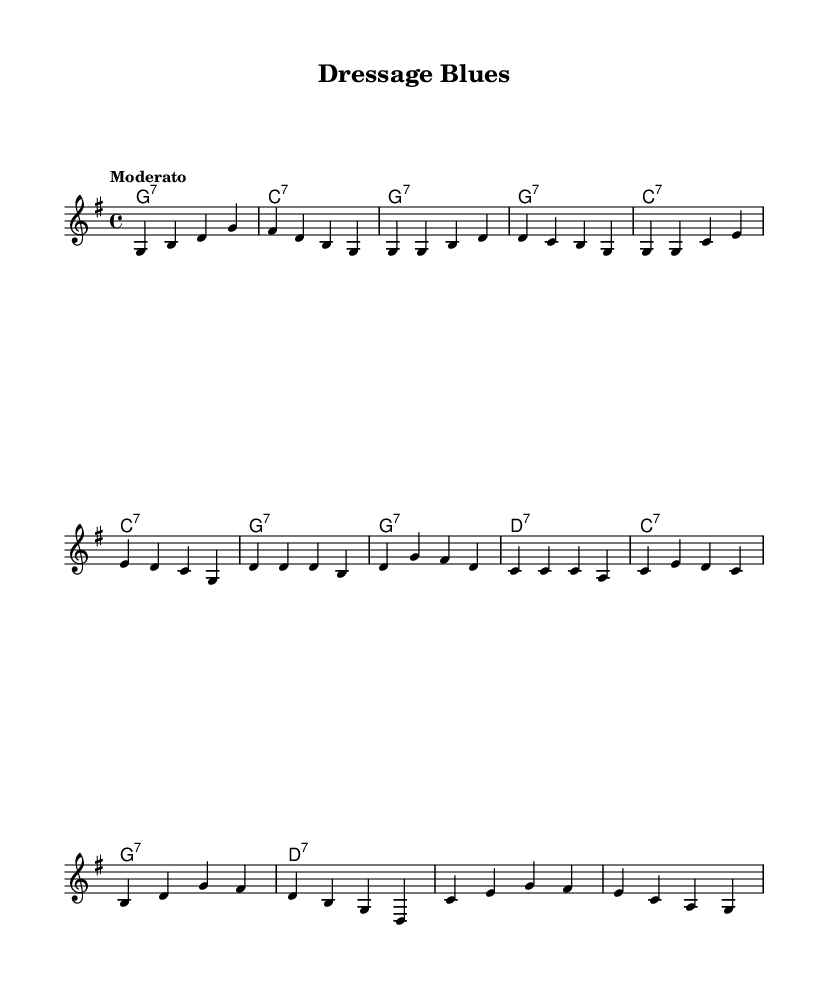What is the key signature of this music? The key signature is G major, which has one sharp (F#). This can be identified by observing the key signature indicated at the beginning of the sheet music.
Answer: G major What is the time signature of this piece? The time signature is 4/4, denoting four beats per measure. It is found at the beginning of the piece right after the key signature.
Answer: 4/4 What is the tempo marking given in the score? The tempo marking is "Moderato," which suggests a moderate speed for the performance. It is placed above the staff at the beginning of the score.
Answer: Moderato How many measures are there in the chorus section? There are four measures in the chorus section, which can be counted by visually identifying the measure lines in the chorus lyrics.
Answer: 4 What is the tonic chord of this composition? The tonic chord is G7. This is determined by looking at the first chord in the harmony section at the beginning, which indicates the home chord for the piece.
Answer: G7 What lyrical themes are portrayed in the bridge? The lyrical themes in the bridge focus on harmony and unity in movement, reflecting a graceful connection between horse and rider. This can be inferred from analyzing the lyrics provided for this section.
Answer: Harmony and unity What form does this blues piece primarily follow? The piece primarily follows a twelve-bar blues structure, identifiable by the repeated chord patterns throughout the verses and chorus. This is a characteristic of many blues pieces.
Answer: Twelve-bar blues 